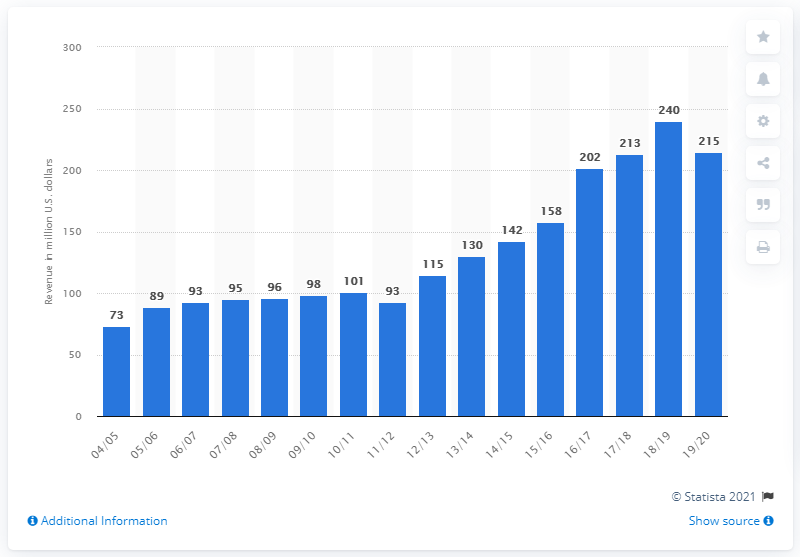List a handful of essential elements in this visual. The estimated revenue of the Charlotte Hornets for the 2019/2020 season is approximately 215 million dollars. 